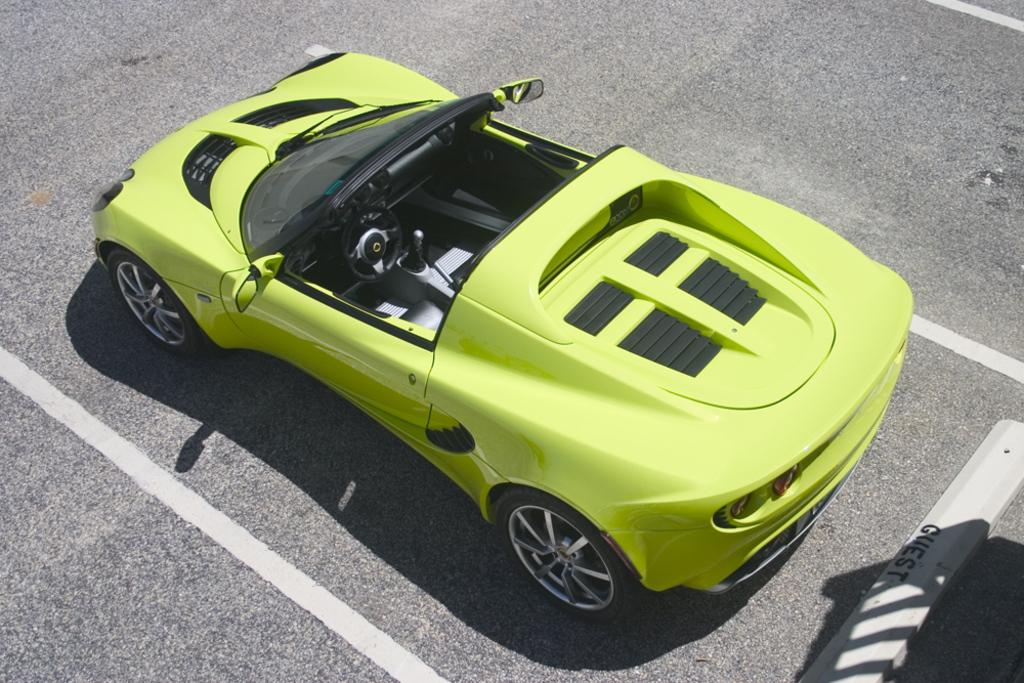What is the main subject of the image? The main subject of the image is a car. Where is the car located in the image? The car is on the road. Can you tell me how many stamps are on the car in the image? There are no stamps present on the car in the image. What type of creature might be crawling alongside the car on the road? There is no creature, such as a snail, crawling alongside the car on the road in the image. 